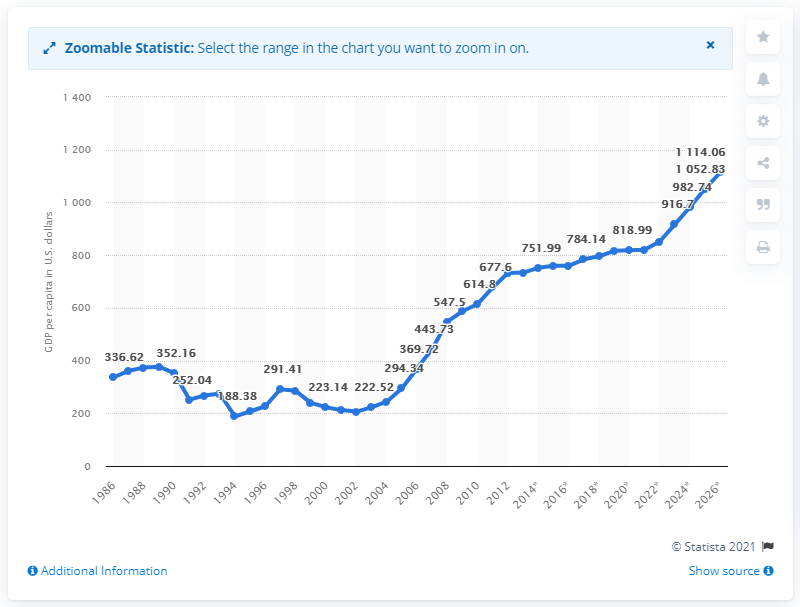Specify some key components in this picture. In 2019, the Gross Domestic Product (GDP) per capita in Rwanda was 816.36. 